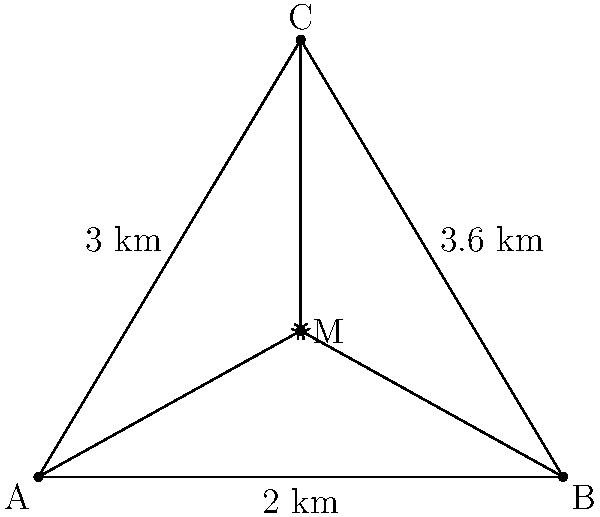For the annual cultural trip, three families from different parts of the neighborhood need to meet at a central location. Their positions form a triangle with sides 2 km, 3 km, and 3.6 km as shown in the diagram. To minimize total travel distance, they decide to meet at the centroid of this triangle. What is the total distance all three families will travel to reach the meeting point? To solve this problem, we'll follow these steps:

1) First, recall that the centroid of a triangle divides each median in the ratio 2:1, with the longer segment closer to the vertex.

2) The distance from each vertex to the centroid is 2/3 of the length of the median from that vertex.

3) We can find the lengths of the medians using the median formula:
   $m_a^2 = \frac{1}{4}(2b^2 + 2c^2 - a^2)$, where $m_a$ is the median to side $a$, and $b$ and $c$ are the other two sides.

4) Let's calculate each median:
   
   For side $a$ (2 km): $m_a^2 = \frac{1}{4}(2(3^2) + 2(3.6^2) - 2^2) = 8.49$
   $m_a = \sqrt{8.49} = 2.91$ km
   
   For side $b$ (3 km): $m_b^2 = \frac{1}{4}(2(2^2) + 2(3.6^2) - 3^2) = 5.49$
   $m_b = \sqrt{5.49} = 2.34$ km
   
   For side $c$ (3.6 km): $m_c^2 = \frac{1}{4}(2(2^2) + 2(3^2) - 3.6^2) = 3.49$
   $m_c = \sqrt{3.49} = 1.87$ km

5) The distance each family travels is 2/3 of these median lengths:
   
   Family A: $\frac{2}{3} * 2.91 = 1.94$ km
   Family B: $\frac{2}{3} * 2.34 = 1.56$ km
   Family C: $\frac{2}{3} * 1.87 = 1.25$ km

6) The total distance is the sum of these three distances:
   $1.94 + 1.56 + 1.25 = 4.75$ km
Answer: 4.75 km 